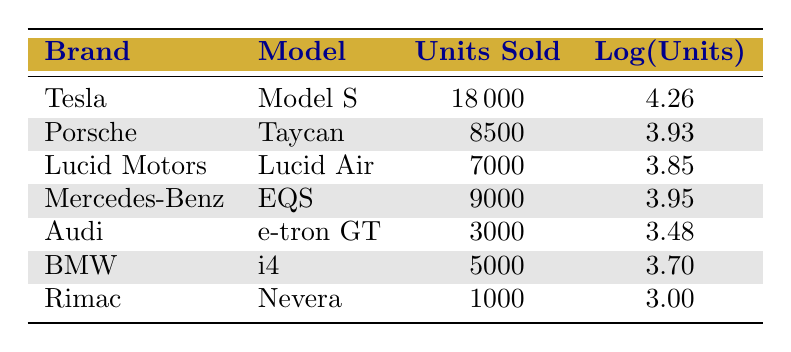What is the total number of units sold by luxury electric vehicle brands listed in the table? By adding the units sold for each brand: 18000 (Tesla) + 8500 (Porsche) + 7000 (Lucid Motors) + 9000 (Mercedes-Benz) + 3000 (Audi) + 5000 (BMW) + 1000 (Rimac) =  18000 + 8500 + 7000 + 9000 + 3000 + 5000 + 1000 =  43500
Answer: 43500 Which brand sold the most units in 2023? The table shows that Tesla sold the highest units at 18000, which is more than any other brand listed.
Answer: Tesla What is the logarithmic value of units sold for the Mercedes-Benz EQS? The table indicates that the logarithmic value for units sold of the Mercedes-Benz EQS is 3.95.
Answer: 3.95 Is it true that Porsche sold more units than Lucid Motors? Comparing the units sold, Porsche sold 8500 while Lucid Motors sold 7000. Since 8500 is greater than 7000, the answer is yes.
Answer: Yes What is the difference in units sold between the brand with the most sales and the brand with the least sales? The most sold brand is Tesla with 18000 units, and the least sold brand is Rimac with 1000 units. The difference is 18000 - 1000 = 17000.
Answer: 17000 What is the average number of units sold across the brands listed? To calculate the average, sum the units sold (43500) and divide by the number of brands (7): 43500 / 7 = 6214.29.
Answer: 6214.29 Did Audi sell more units than BMW in 2023? Audi sold 3000 units and BMW sold 5000 units, so BMW sold more than Audi, meaning the answer is no.
Answer: No Which brands sold more than 7000 units? The brands that sold more than 7000 units are Tesla (18000), Porsche (8500), and Mercedes-Benz (9000).
Answer: Tesla, Porsche, Mercedes-Benz What is the percent of total sales contributed by Rimac? Rimac sold 1000 units, and the total sales were 43500. The percentage is (1000 / 43500) * 100 = 2.30.
Answer: 2.30% 